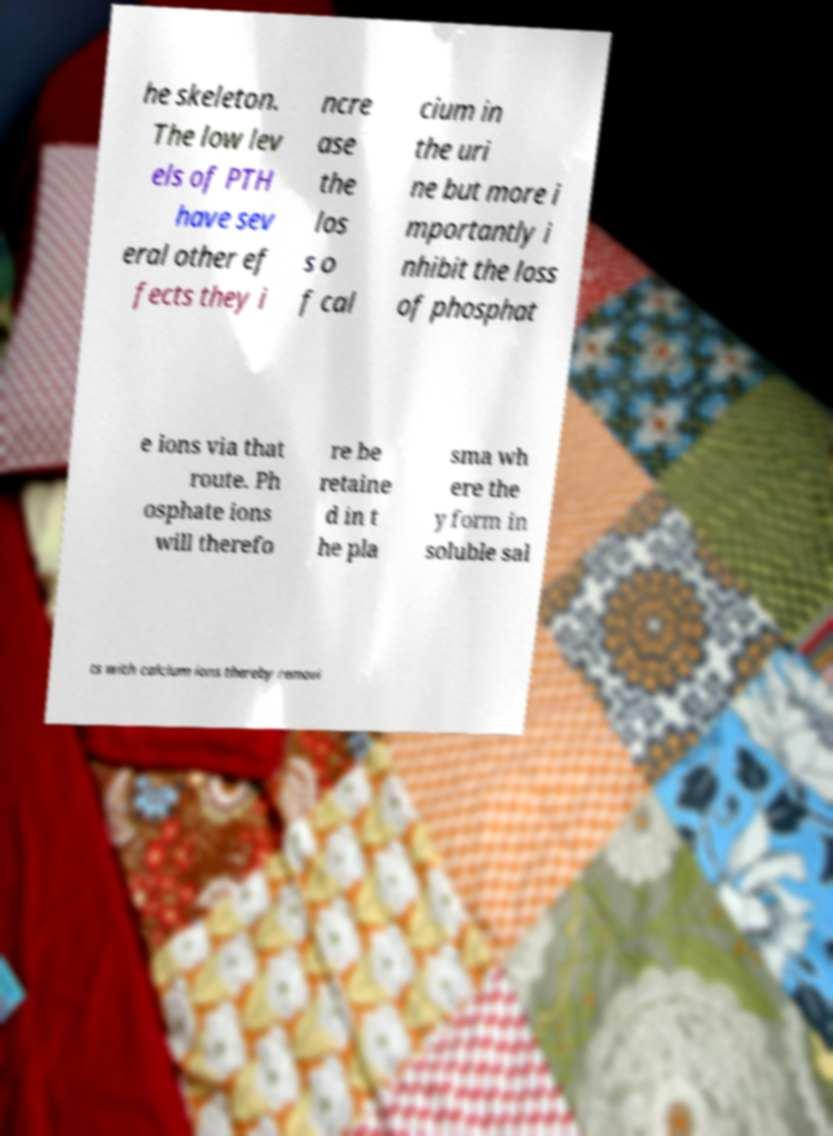Can you accurately transcribe the text from the provided image for me? he skeleton. The low lev els of PTH have sev eral other ef fects they i ncre ase the los s o f cal cium in the uri ne but more i mportantly i nhibit the loss of phosphat e ions via that route. Ph osphate ions will therefo re be retaine d in t he pla sma wh ere the y form in soluble sal ts with calcium ions thereby removi 